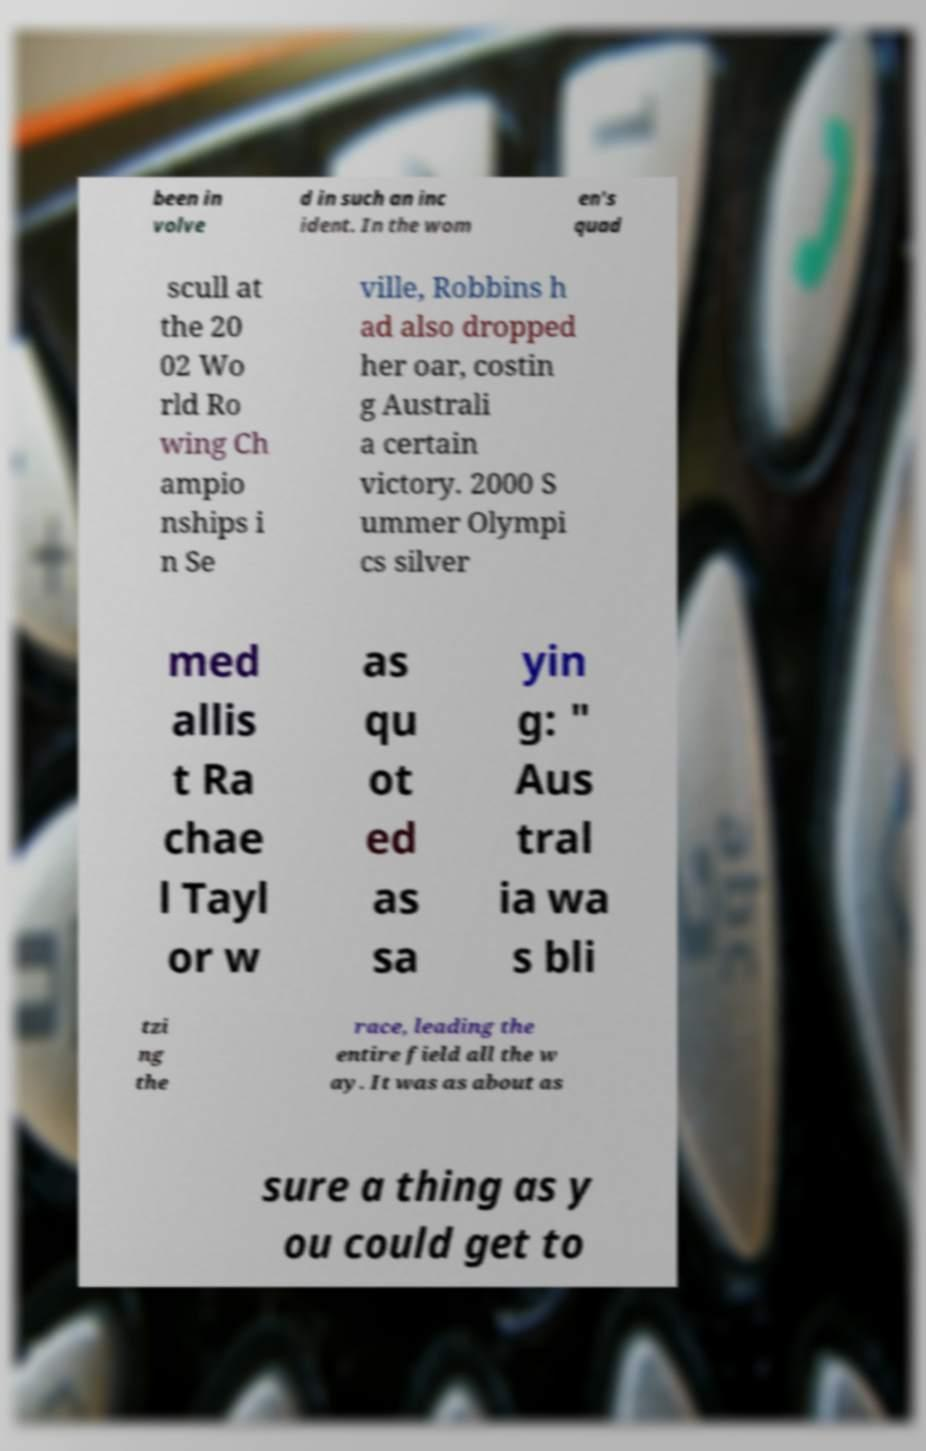Please identify and transcribe the text found in this image. been in volve d in such an inc ident. In the wom en's quad scull at the 20 02 Wo rld Ro wing Ch ampio nships i n Se ville, Robbins h ad also dropped her oar, costin g Australi a certain victory. 2000 S ummer Olympi cs silver med allis t Ra chae l Tayl or w as qu ot ed as sa yin g: " Aus tral ia wa s bli tzi ng the race, leading the entire field all the w ay. It was as about as sure a thing as y ou could get to 